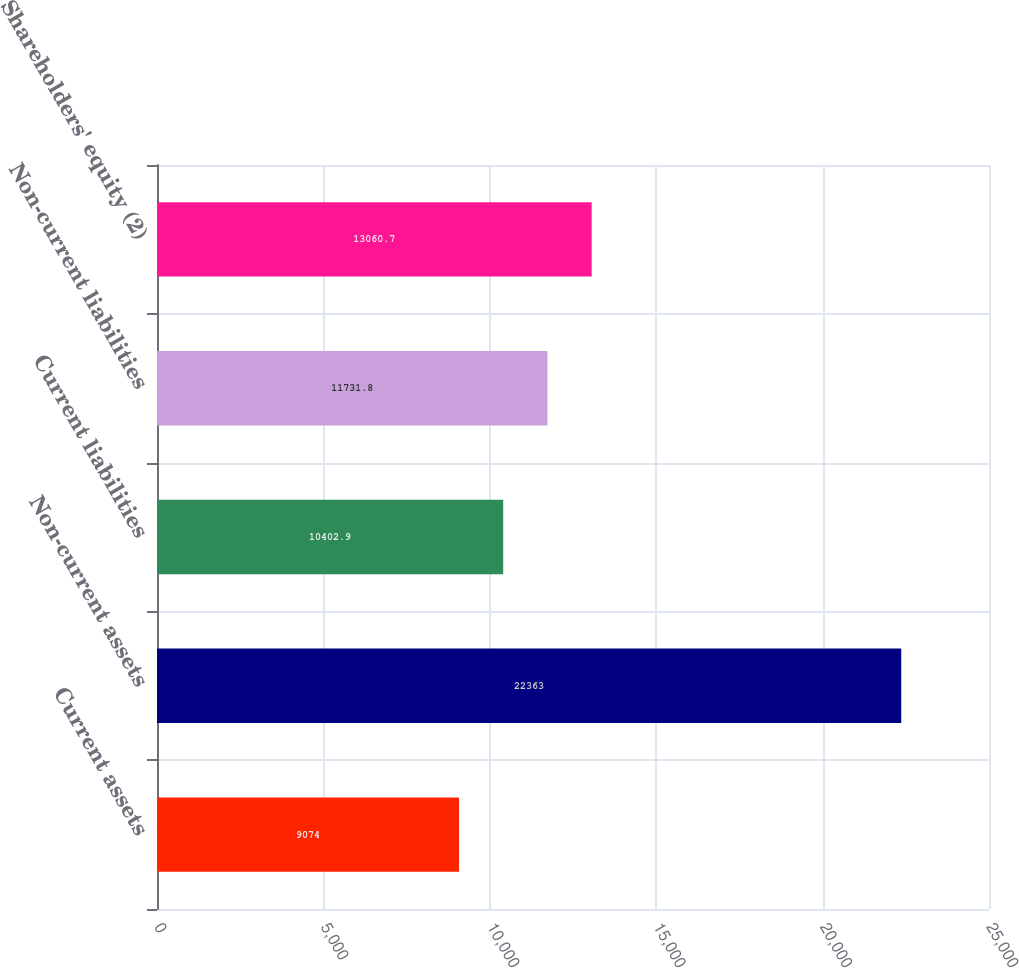Convert chart to OTSL. <chart><loc_0><loc_0><loc_500><loc_500><bar_chart><fcel>Current assets<fcel>Non-current assets<fcel>Current liabilities<fcel>Non-current liabilities<fcel>Shareholders' equity (2)<nl><fcel>9074<fcel>22363<fcel>10402.9<fcel>11731.8<fcel>13060.7<nl></chart> 